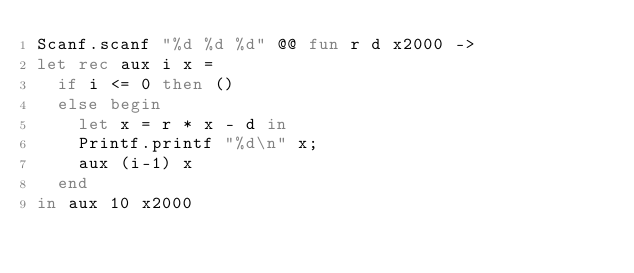<code> <loc_0><loc_0><loc_500><loc_500><_OCaml_>Scanf.scanf "%d %d %d" @@ fun r d x2000 ->
let rec aux i x =
  if i <= 0 then ()
  else begin
    let x = r * x - d in
    Printf.printf "%d\n" x;
    aux (i-1) x
  end
in aux 10 x2000
</code> 